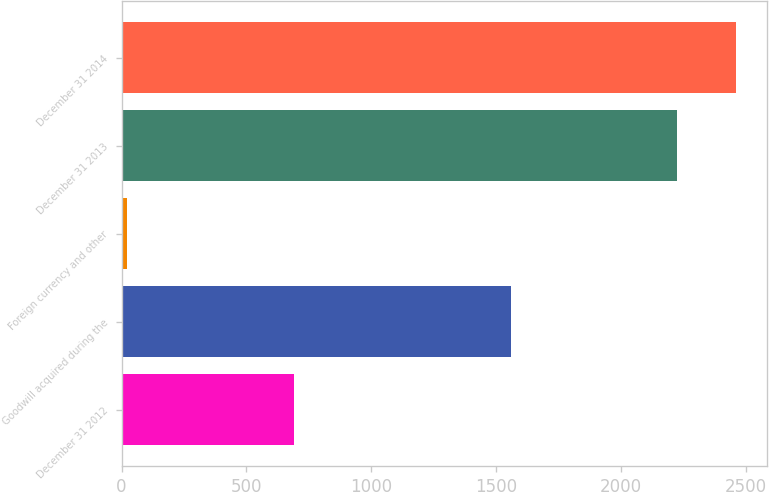Convert chart to OTSL. <chart><loc_0><loc_0><loc_500><loc_500><bar_chart><fcel>December 31 2012<fcel>Goodwill acquired during the<fcel>Foreign currency and other<fcel>December 31 2013<fcel>December 31 2014<nl><fcel>691<fcel>1559<fcel>23<fcel>2227<fcel>2463.3<nl></chart> 